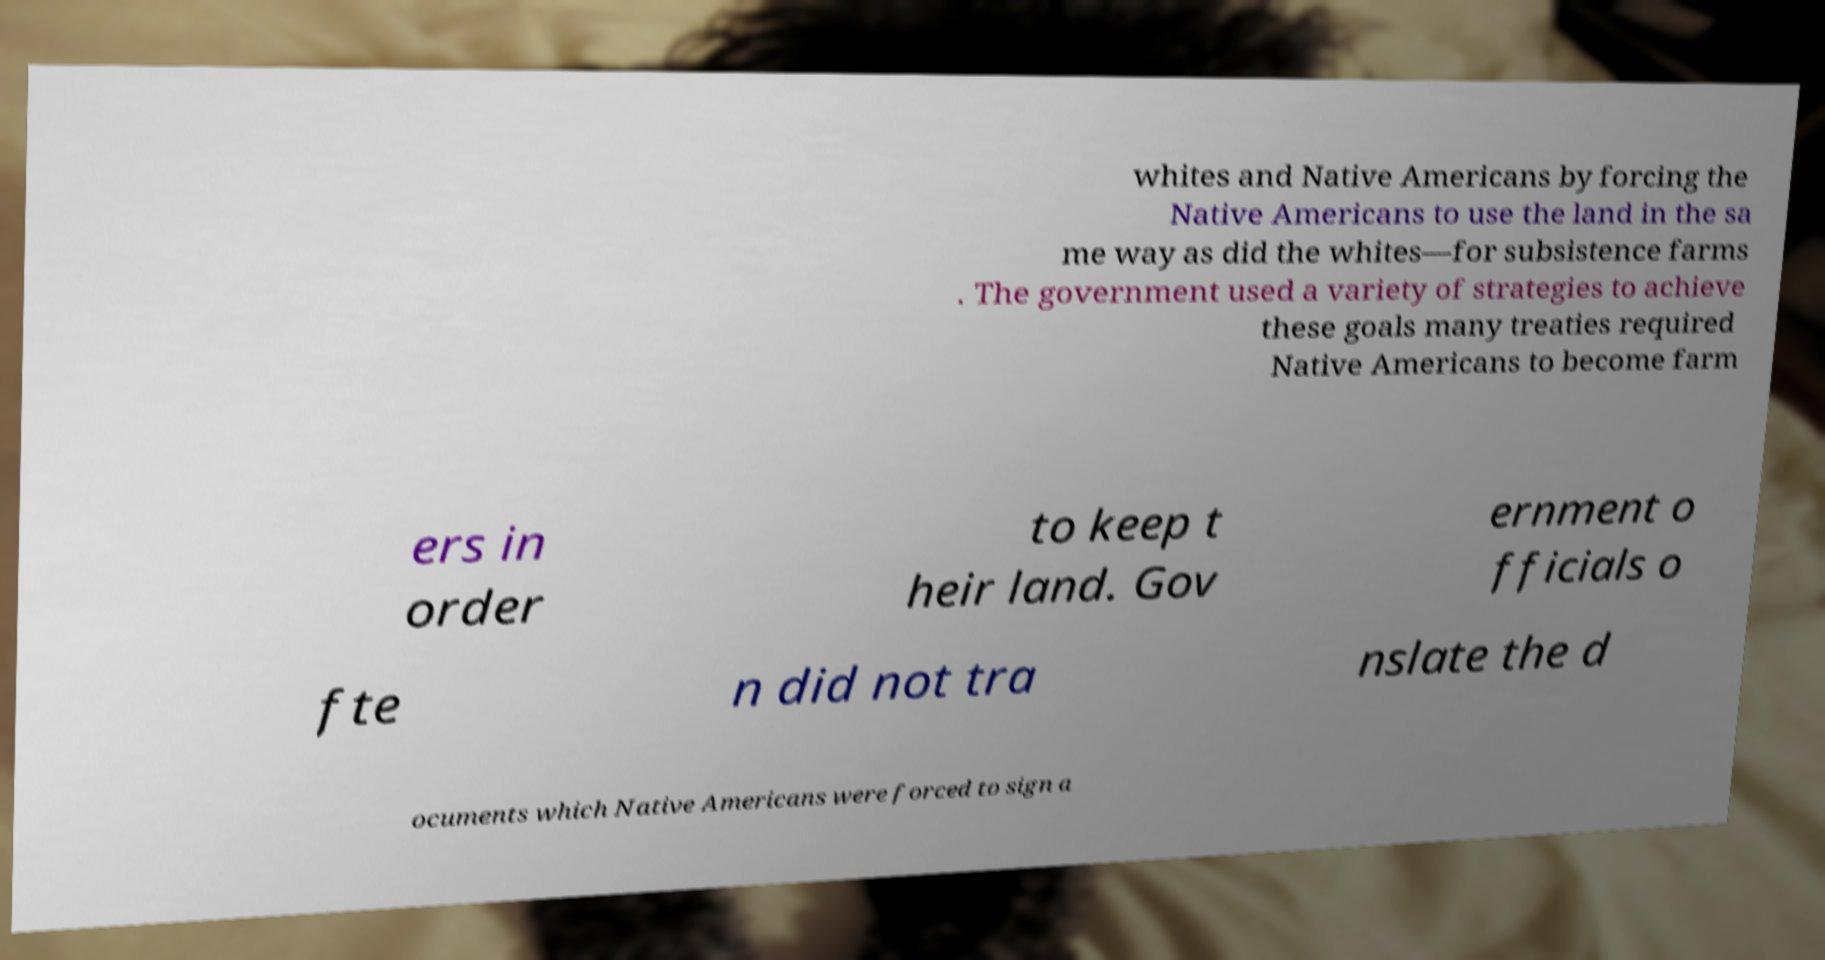Could you assist in decoding the text presented in this image and type it out clearly? whites and Native Americans by forcing the Native Americans to use the land in the sa me way as did the whites—for subsistence farms . The government used a variety of strategies to achieve these goals many treaties required Native Americans to become farm ers in order to keep t heir land. Gov ernment o fficials o fte n did not tra nslate the d ocuments which Native Americans were forced to sign a 